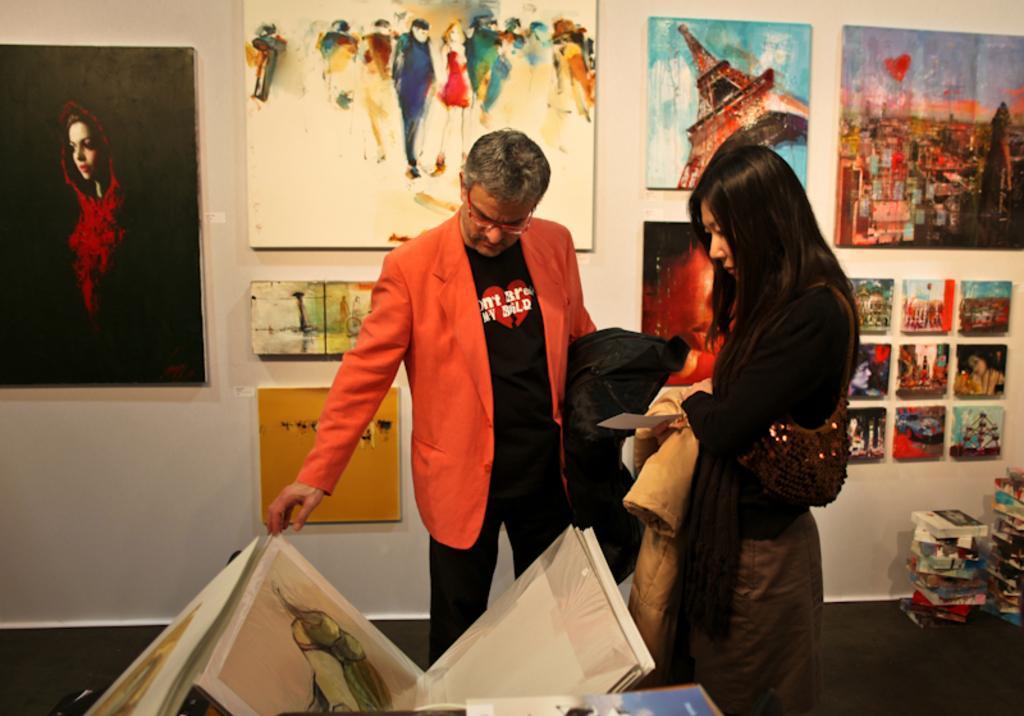Could you give a brief overview of what you see in this image? Paintings are on the wall. This woman wore bag and holding a card. This man is looking at this painting. These are books.  